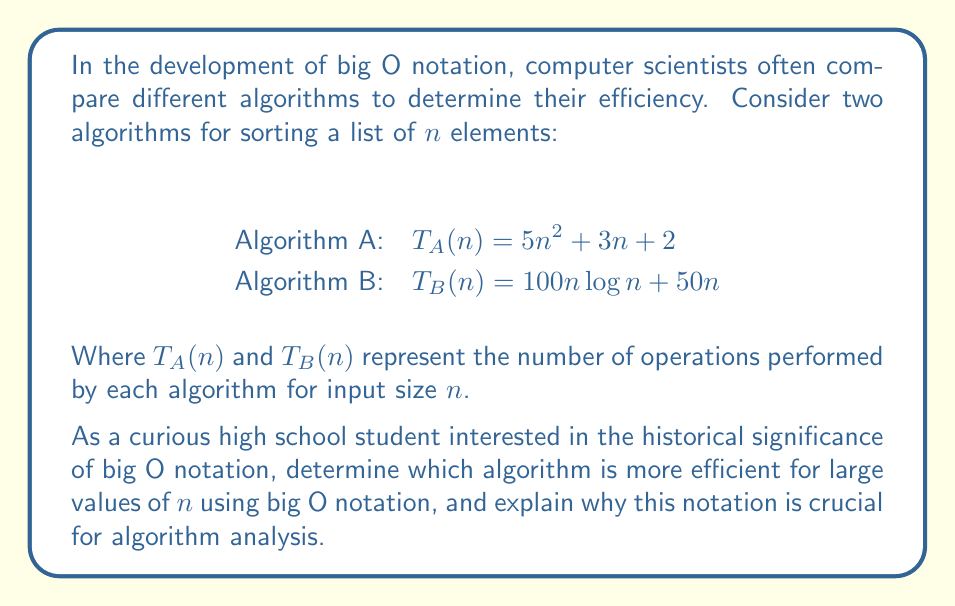Show me your answer to this math problem. To answer this question, let's break it down into steps:

1) First, we need to understand what big O notation represents. Big O notation describes the upper bound of the growth rate of an algorithm's time complexity as the input size increases. It focuses on the dominant term of the function as $n$ approaches infinity.

2) For Algorithm A: $T_A(n) = 5n^2 + 3n + 2$
   The dominant term is $n^2$, so we can say $T_A(n) = O(n^2)$

3) For Algorithm B: $T_B(n) = 100n\log n + 50n$
   The dominant term is $n\log n$, so we can say $T_B(n) = O(n\log n)$

4) To compare these, we need to understand that $n\log n$ grows more slowly than $n^2$ for large values of $n$. We can visualize this:

   [asy]
   import graph;
   size(200,200);
   real f(real x) {return x^2;}
   real g(real x) {return x*log(x);}
   draw(graph(f,1,10));
   draw(graph(g,1,10),dashed);
   xaxis("n",0,10,Arrow);
   yaxis("T(n)",0,100,Arrow);
   label("$n^2$",(8,f(8)),E);
   label("$n\log n$",(8,g(8)),W);
   [/asy]

5) Therefore, Algorithm B (with $O(n\log n)$) is more efficient for large values of $n$.

The historical significance of big O notation in algorithm analysis is crucial because:

a) It provides a standardized way to compare algorithms, regardless of implementation details or specific hardware.

b) It focuses on the algorithm's behavior with large input sizes, which is often most critical in real-world applications.

c) It simplifies the comparison by ignoring constant factors and lower-order terms, which become less significant as $n$ increases.

d) It allows computer scientists to classify algorithms into efficiency classes (e.g., linear, logarithmic, quadratic), facilitating discussions about algorithm design and improvement.
Answer: Algorithm B with $O(n\log n)$ is more efficient for large values of $n$. Big O notation is crucial for algorithm analysis as it provides a standardized, simplified method to compare algorithm efficiency, focusing on behavior with large inputs and facilitating classification of algorithms into efficiency classes. 